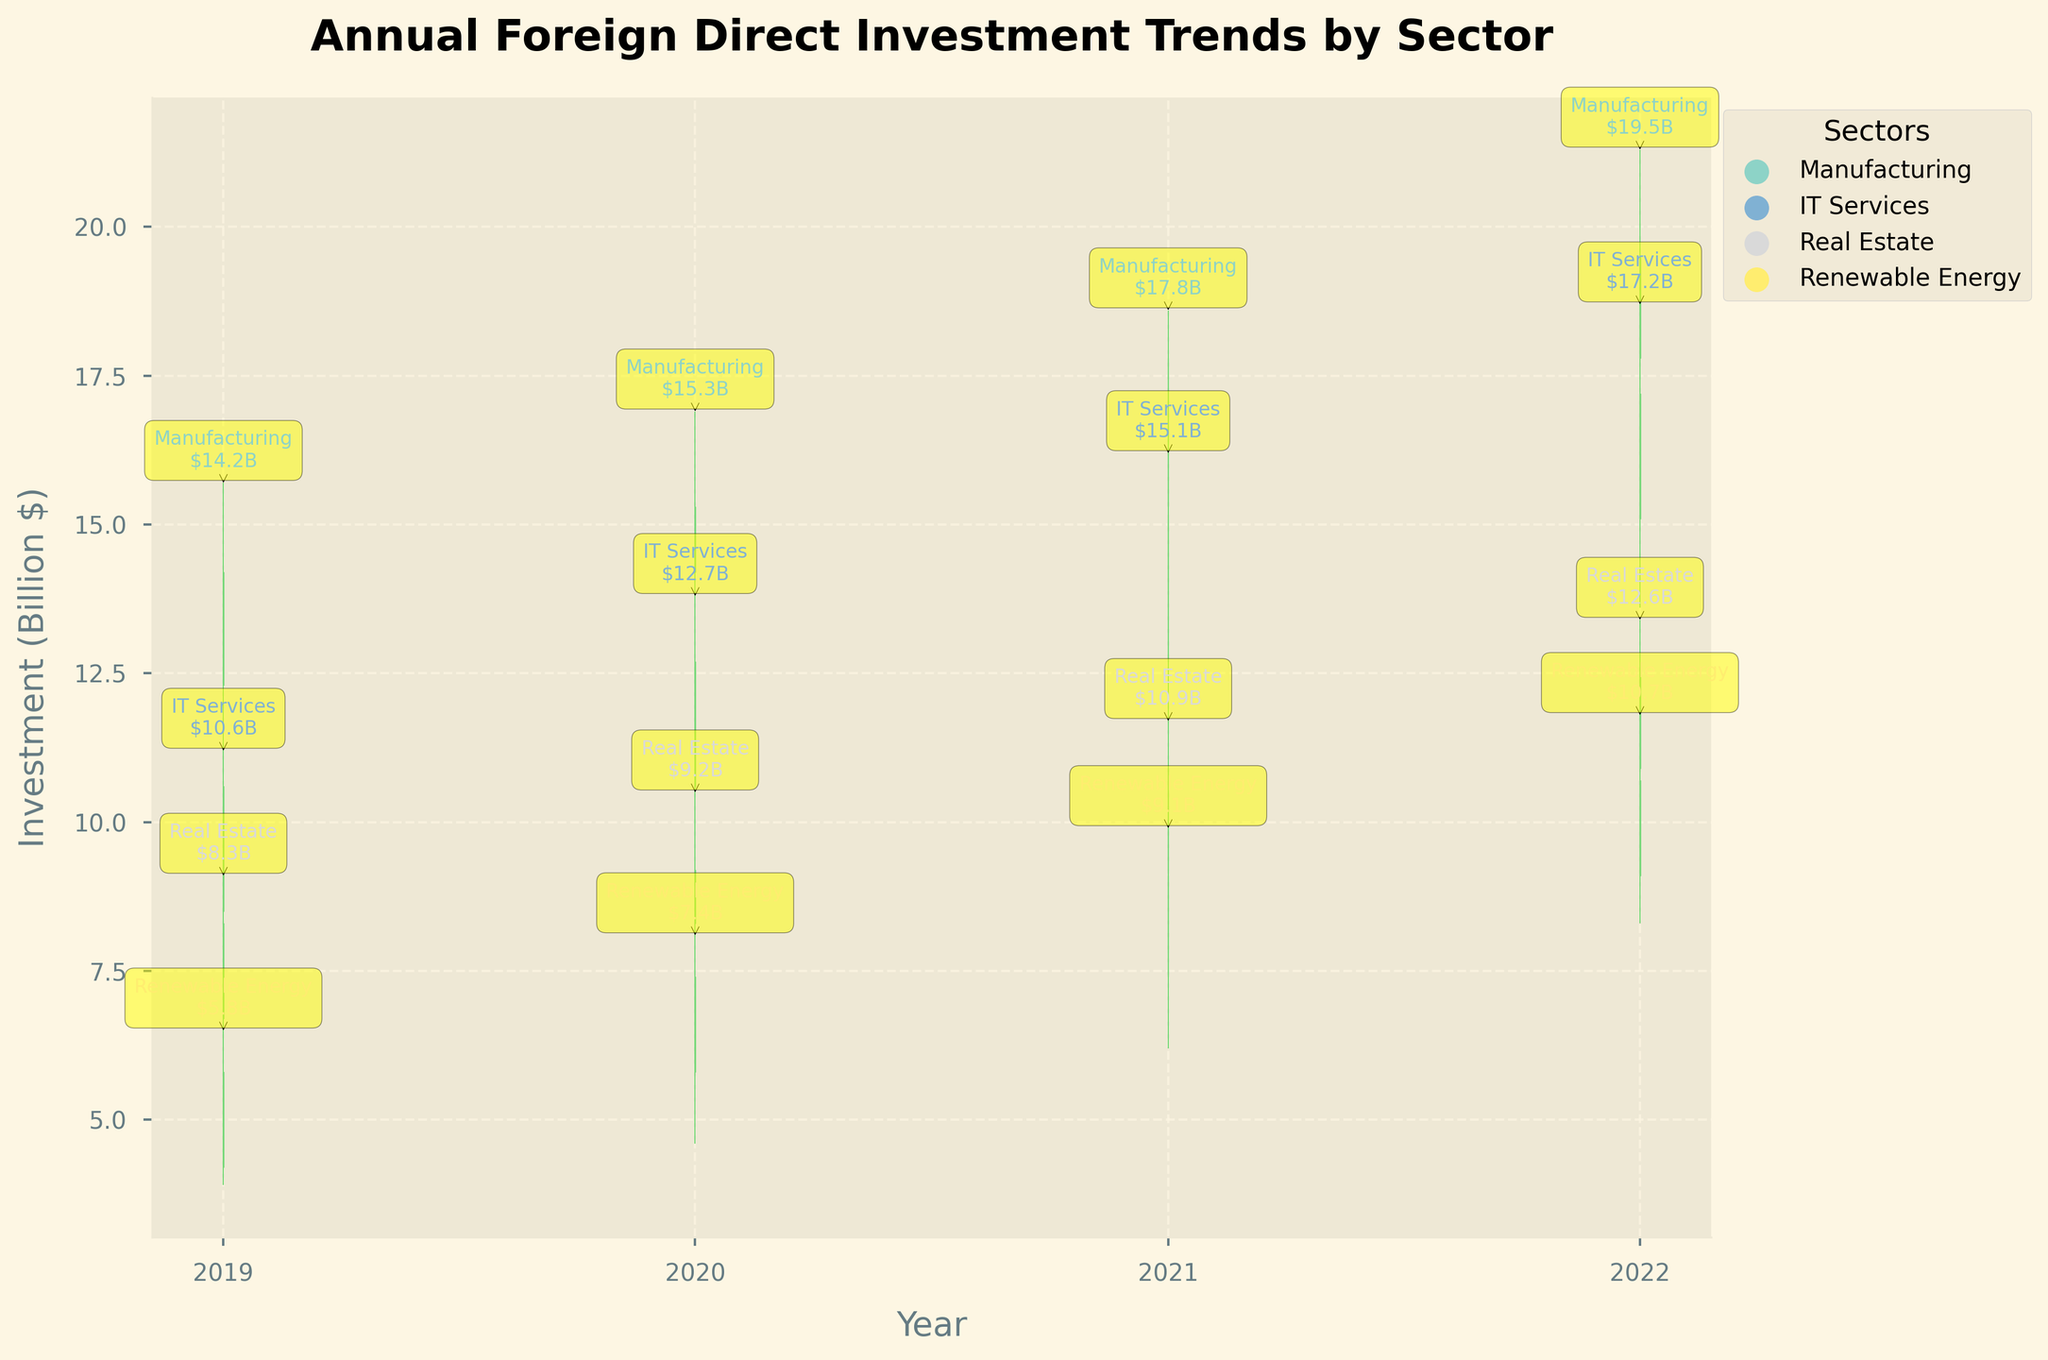Which sector had the highest closing investment in 2022? To find the sector with the highest closing investment in 2022, locate the bars representing 2022 and compare the closing values (the final plotted points) of each sector. The highest closing point for 2022 is "Manufacturing" with a value of 19.5 billion $.
Answer: Manufacturing How did the investment in IT Services change from 2020 to 2021? Look at the opening and closing values for IT Services in 2020 and 2021. The closing value in 2020 was 12.7 billion $, and in 2021 it was 15.1 billion $. The change is 15.1 - 12.7 billion $ = 2.4 billion $.
Answer: Increased by 2.4 billion $ What's the highest investment in Real Estate in the entire period? Examine the high points of the bars for Real Estate across all years. The highest peak for Real Estate occurs in 2022 with a high value of 13.4 billion $.
Answer: 13.4 billion $ Which sector showed the most significant increase in investment from 2019 to 2022? Compare the closing values for each sector in 2019 and 2022. Subtract the 2019 values from the 2022 values for each sector. The sector with the highest difference is Manufacturing, which increased from 14.2 billion $ to 19.5 billion $, yielding a difference of 19.5 - 14.2 = 5.3 billion $.
Answer: Manufacturing What was the lowest point of investment in Renewable Energy over the entire period? Identify the lowest points of the bars for Renewable Energy across all years. The lowest value is 3.9 billion $ in 2019.
Answer: 3.9 billion $ How many sectors had their highest investment peak in 2022? Check the highest points (peaks) of the bars for all sectors in each year. Count the number of sectors whose highest peak occurred in 2022. All sectors (Manufacturing, IT Services, Real Estate, Renewable Energy) had their highest peaks in 2022.
Answer: 4 Did any sector experience a decrease in investment from 2021 to 2022? Compare the closing values for each sector from 2021 to 2022. Real Estate decreased from 10.9 billion $ to 12.6 billion $, but this is not a decrease. Thus, none of the sectors experienced a decrease.
Answer: No What was the average closing investment for Renewable Energy from 2019 to 2022? Sum the closing investments for Renewable Energy from 2019 to 2022 and divide by the number of years. The values are 5.8, 7.4, 9.1, and 10.7 billion $. The sum is 33 and the average is 33/4 = 8.25 billion $.
Answer: 8.25 billion $ 